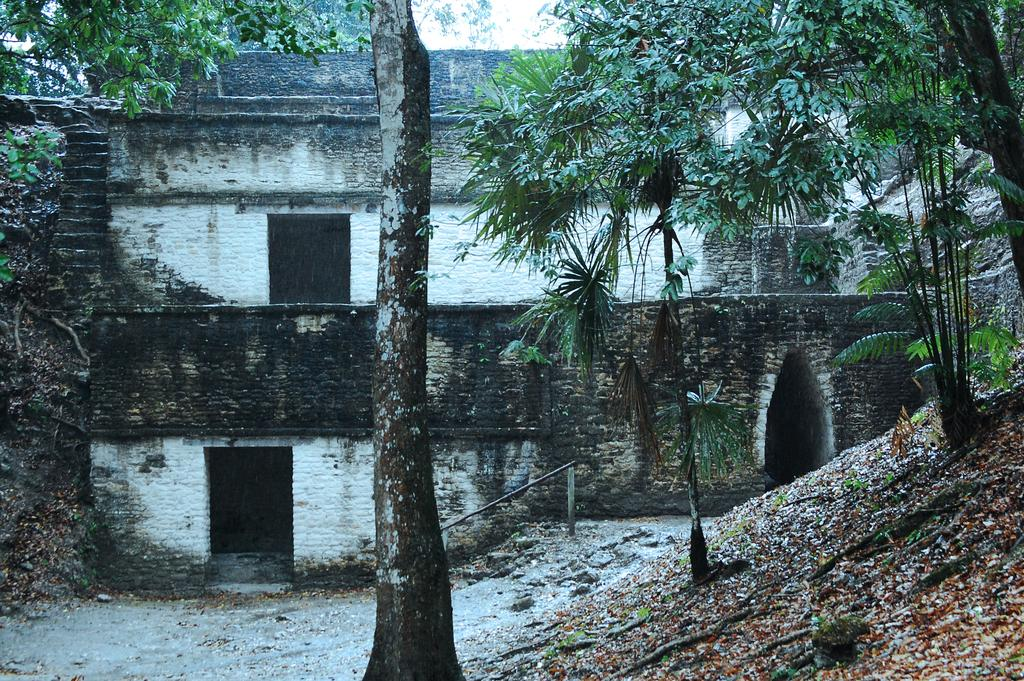What types of vegetation can be seen in the foreground of the picture? Plants and trees are visible in the foreground of the picture. What else can be found in the foreground of the picture? Dry leaves and roots are present in the foreground of the picture. What is located in the center of the picture? There is an old construction in the center of the picture. What types of vegetation can be seen in the center of the picture? Trees are present in the center of the picture. How does the secretary feel about the fog in the image? There is no secretary or fog present in the image. What type of love is depicted in the image? There is no depiction of love in the image; it features plants, trees, dry leaves, roots, and an old construction. 